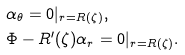<formula> <loc_0><loc_0><loc_500><loc_500>& \alpha _ { \theta } = 0 | _ { r = R ( \zeta ) } , \\ & \Phi - R ^ { \prime } ( \zeta ) \alpha _ { r } = 0 | _ { r = R ( \zeta ) } .</formula> 